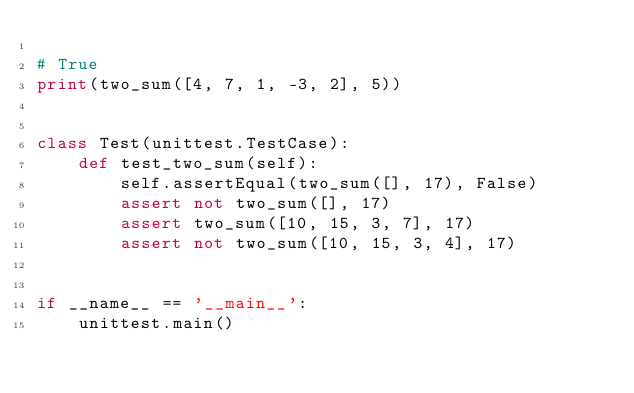Convert code to text. <code><loc_0><loc_0><loc_500><loc_500><_Python_>
# True
print(two_sum([4, 7, 1, -3, 2], 5))


class Test(unittest.TestCase):
    def test_two_sum(self):
        self.assertEqual(two_sum([], 17), False)
        assert not two_sum([], 17)
        assert two_sum([10, 15, 3, 7], 17)
        assert not two_sum([10, 15, 3, 4], 17)


if __name__ == '__main__':
    unittest.main()
</code> 